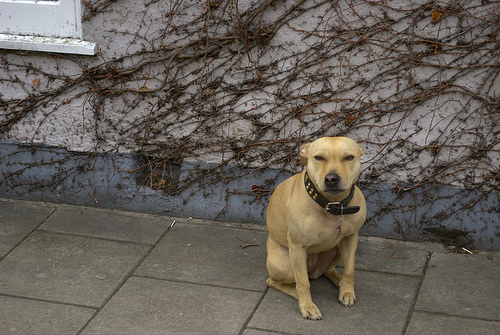What animal is it? The animal in the image is a dog, which appears to be a Labrador Retriever, known for their friendly nature and often used as guide dogs or in search-and-rescue missions. 